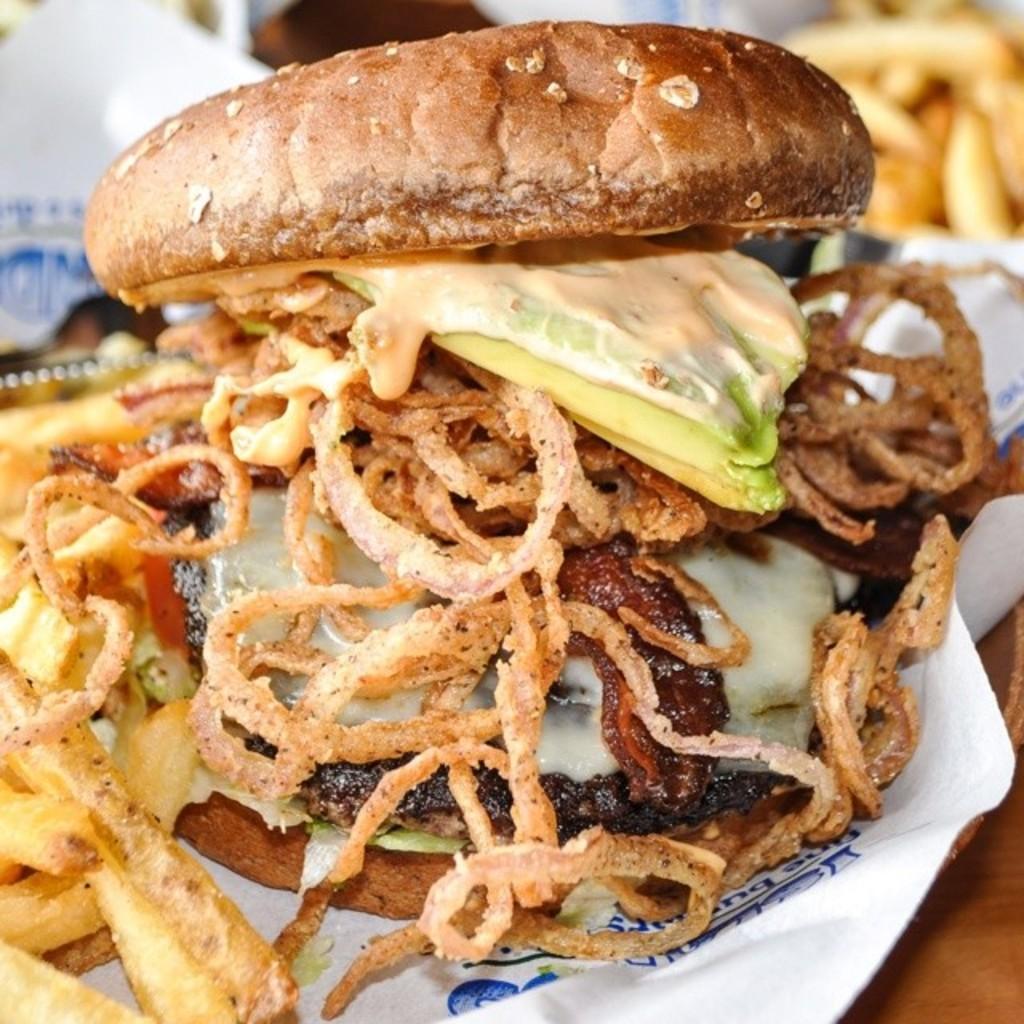Please provide a concise description of this image. In this picture we can see food item and tissue paper are present on the table. 